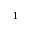Convert formula to latex. <formula><loc_0><loc_0><loc_500><loc_500>^ { 1 }</formula> 